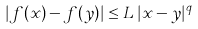Convert formula to latex. <formula><loc_0><loc_0><loc_500><loc_500>| f ( x ) - f ( y ) | \leq L \, | x - y | ^ { q }</formula> 